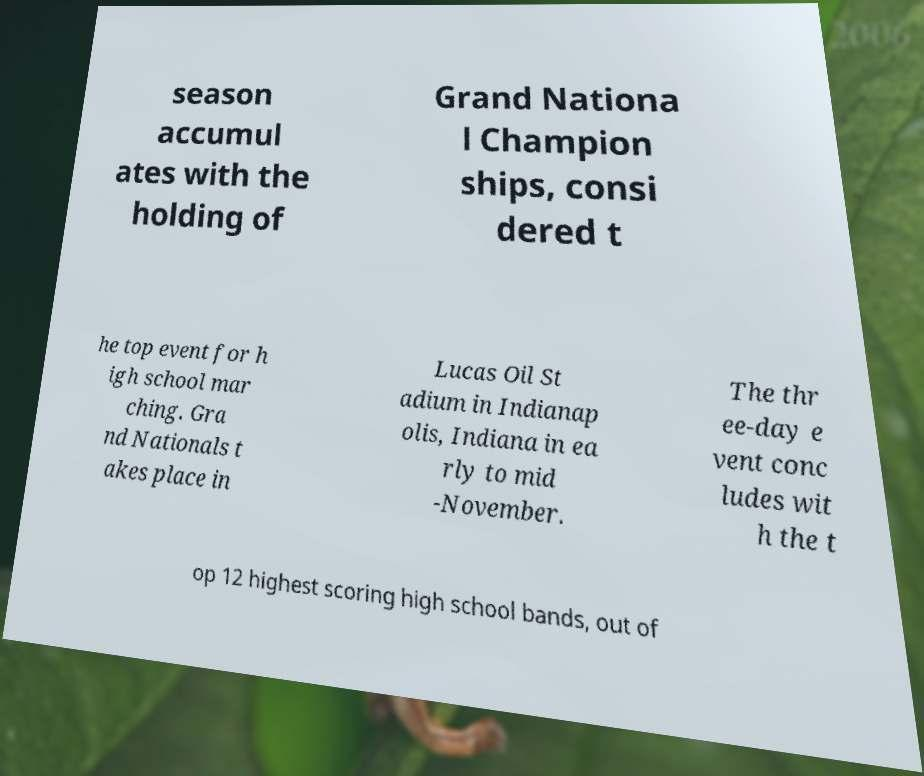Could you assist in decoding the text presented in this image and type it out clearly? season accumul ates with the holding of Grand Nationa l Champion ships, consi dered t he top event for h igh school mar ching. Gra nd Nationals t akes place in Lucas Oil St adium in Indianap olis, Indiana in ea rly to mid -November. The thr ee-day e vent conc ludes wit h the t op 12 highest scoring high school bands, out of 